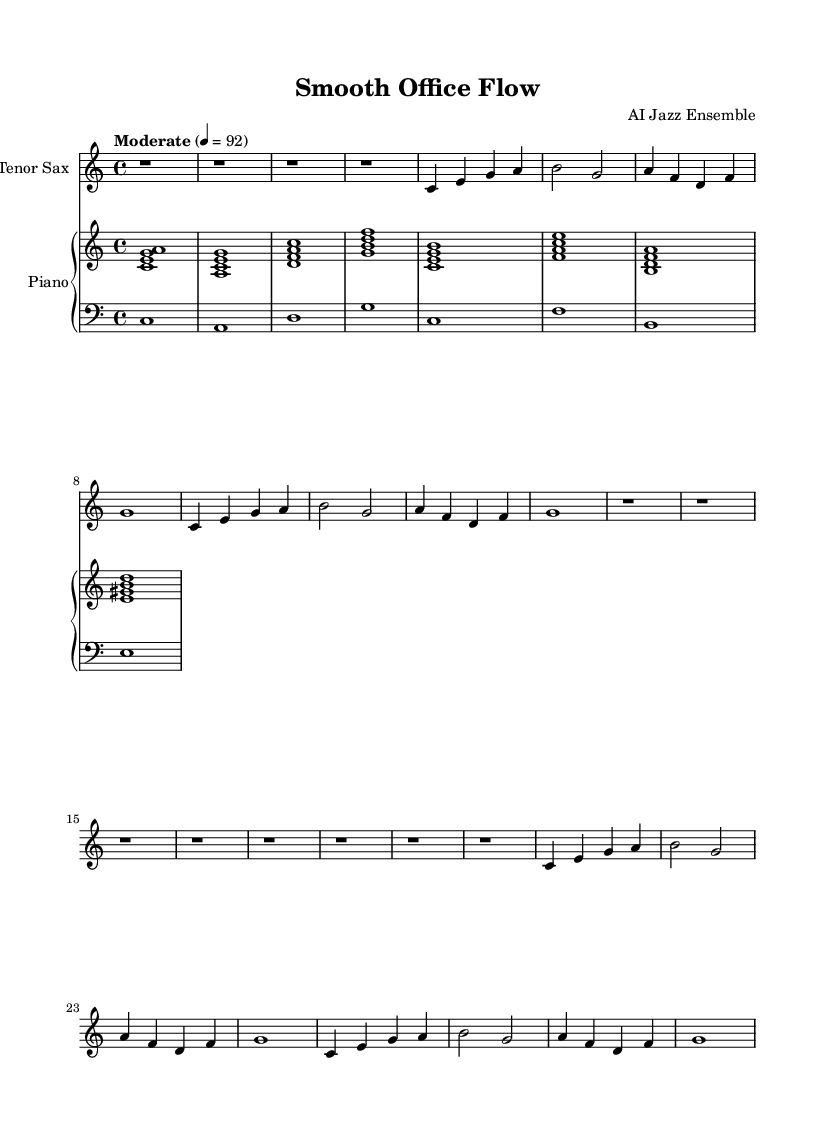What is the key signature of this music? The key signature shows no sharps or flats, indicating that the piece is in C major.
Answer: C major What is the time signature of this music? The time signature is represented as 4/4, meaning there are four beats per measure.
Answer: 4/4 What is the tempo of the piece? The tempo marking indicates a moderate speed of 92 beats per minute.
Answer: 92 How many bars are in the A section? The A section consists of two repetitions of 8 bars each, totaling 16 bars.
Answer: 16 bars What instruments are featured in this score? The score includes a tenor saxophone and a piano with upper and lower staffs.
Answer: Tenor Sax, Piano What is the rhythm pattern of the B section? The B section has a resting rhythm for all measures, indicating silence and no played notes.
Answer: Silence How many different chords are used in the piano part? The piano part includes a sequence of seven different chords as indicated in the upper staff.
Answer: Seven 